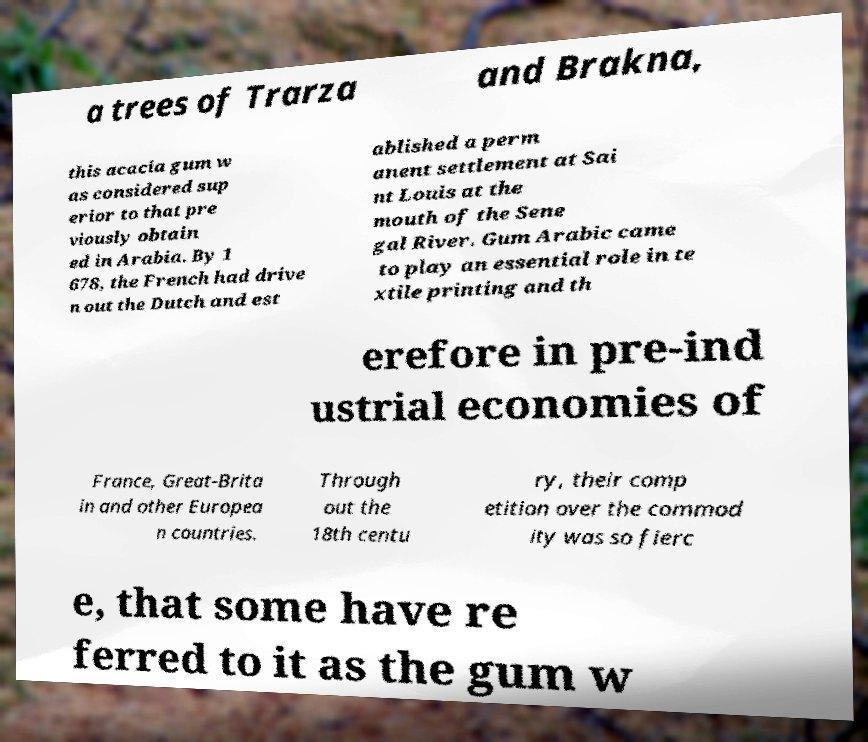Can you accurately transcribe the text from the provided image for me? a trees of Trarza and Brakna, this acacia gum w as considered sup erior to that pre viously obtain ed in Arabia. By 1 678, the French had drive n out the Dutch and est ablished a perm anent settlement at Sai nt Louis at the mouth of the Sene gal River. Gum Arabic came to play an essential role in te xtile printing and th erefore in pre-ind ustrial economies of France, Great-Brita in and other Europea n countries. Through out the 18th centu ry, their comp etition over the commod ity was so fierc e, that some have re ferred to it as the gum w 